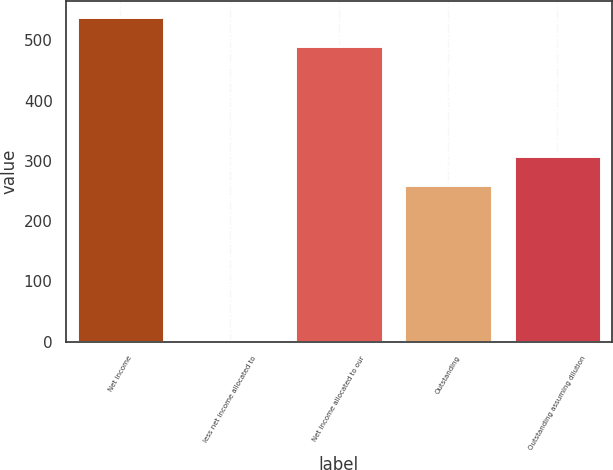<chart> <loc_0><loc_0><loc_500><loc_500><bar_chart><fcel>Net income<fcel>less net income allocated to<fcel>Net income allocated to our<fcel>Outstanding<fcel>Outstanding assuming dilution<nl><fcel>538.67<fcel>1.1<fcel>489.7<fcel>259.3<fcel>308.27<nl></chart> 